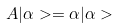<formula> <loc_0><loc_0><loc_500><loc_500>A | \alpha > = \alpha | \alpha ></formula> 